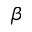<formula> <loc_0><loc_0><loc_500><loc_500>\beta</formula> 